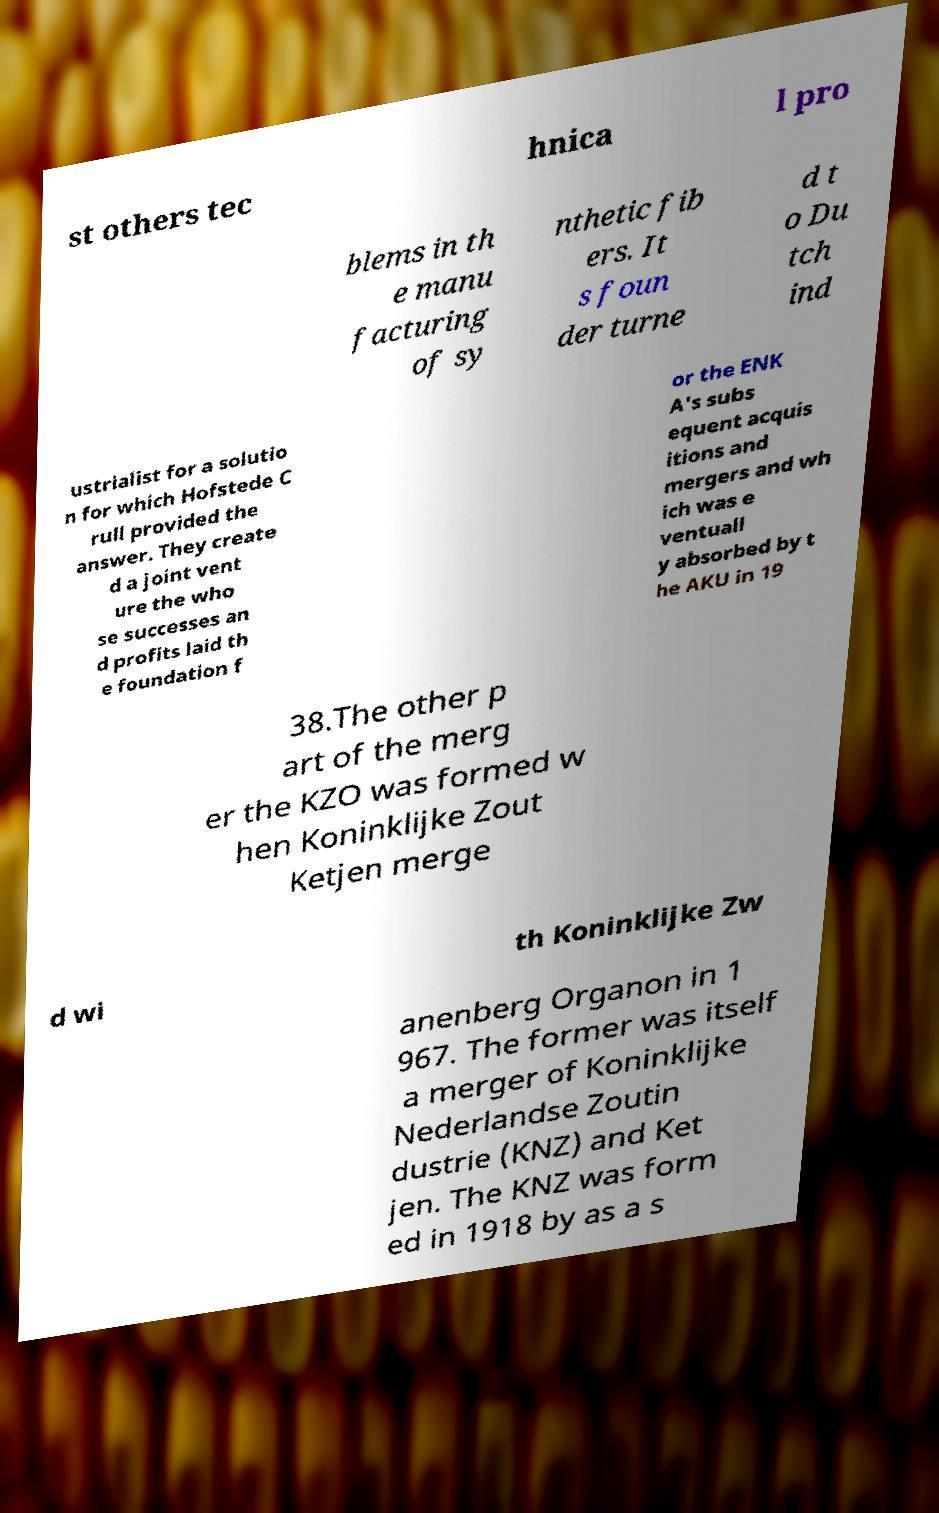I need the written content from this picture converted into text. Can you do that? st others tec hnica l pro blems in th e manu facturing of sy nthetic fib ers. It s foun der turne d t o Du tch ind ustrialist for a solutio n for which Hofstede C rull provided the answer. They create d a joint vent ure the who se successes an d profits laid th e foundation f or the ENK A's subs equent acquis itions and mergers and wh ich was e ventuall y absorbed by t he AKU in 19 38.The other p art of the merg er the KZO was formed w hen Koninklijke Zout Ketjen merge d wi th Koninklijke Zw anenberg Organon in 1 967. The former was itself a merger of Koninklijke Nederlandse Zoutin dustrie (KNZ) and Ket jen. The KNZ was form ed in 1918 by as a s 